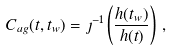<formula> <loc_0><loc_0><loc_500><loc_500>C _ { a g } ( t , t _ { w } ) = \jmath ^ { - 1 } \left ( \frac { h ( t _ { w } ) } { h ( t ) } \right ) \, ,</formula> 